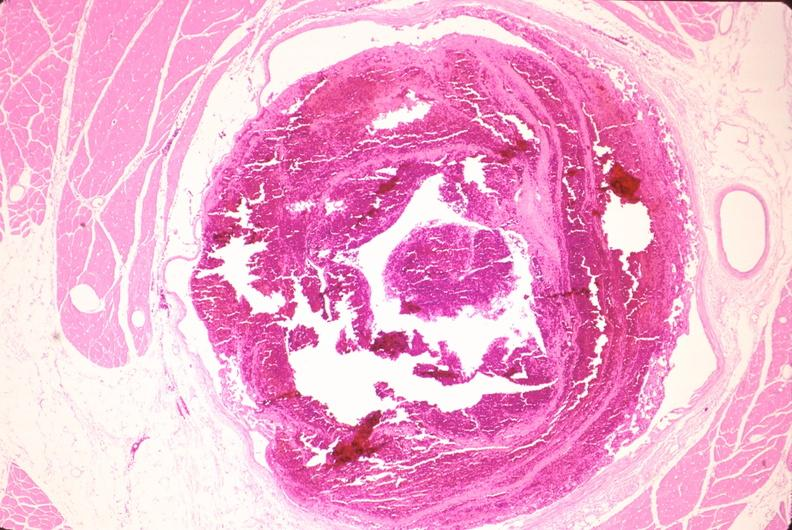what is present?
Answer the question using a single word or phrase. Cardiovascular 